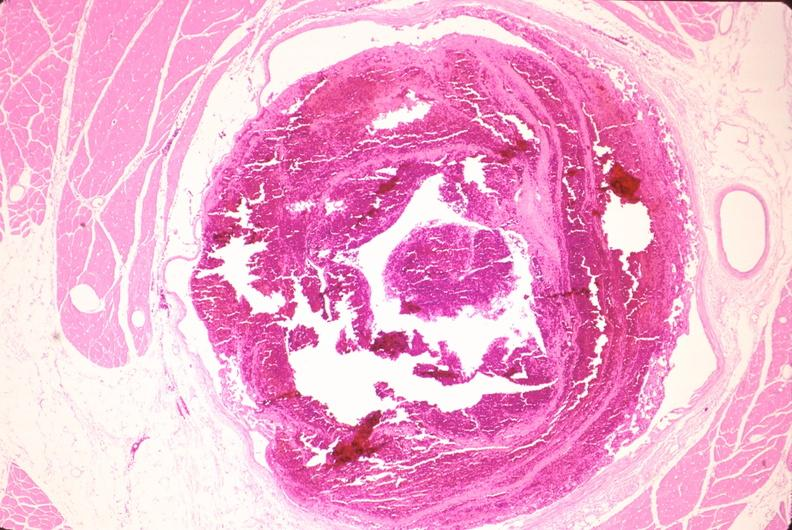what is present?
Answer the question using a single word or phrase. Cardiovascular 